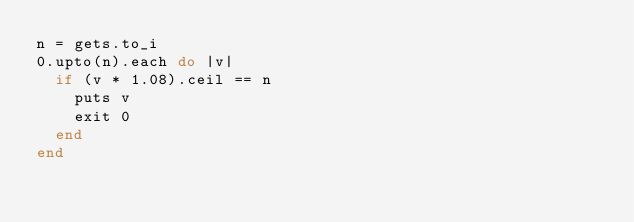Convert code to text. <code><loc_0><loc_0><loc_500><loc_500><_Ruby_>n = gets.to_i
0.upto(n).each do |v|
  if (v * 1.08).ceil == n
    puts v
    exit 0
  end
end
</code> 